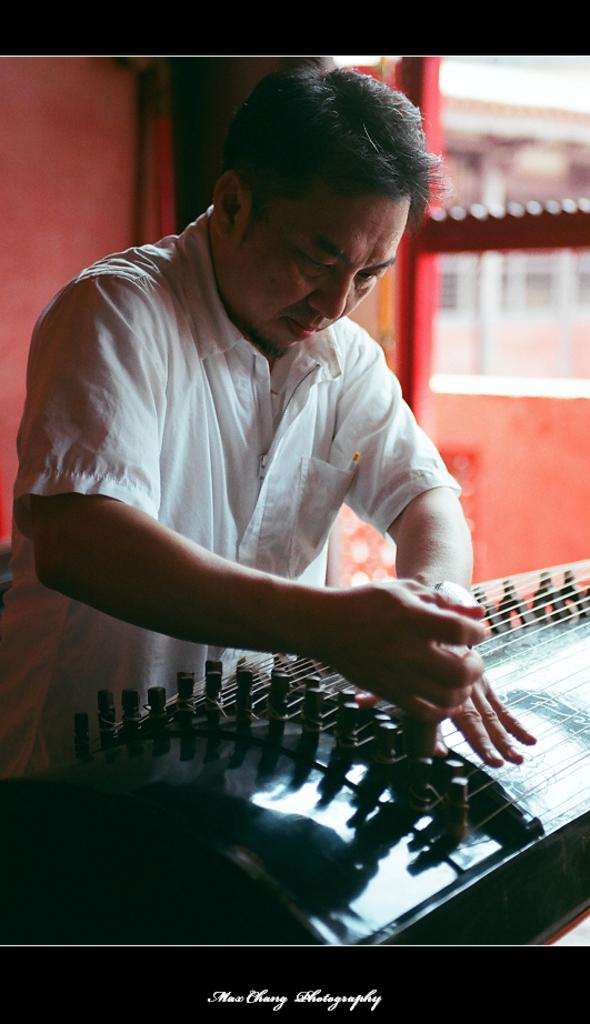Who is present in the image? There is a man in the image. What is the man wearing? The man is wearing clothes. What object can be seen in the image besides the man? There is a musical instrument in the image. Can you describe the background of the image? The background of the image is slightly blurred. What type of wrench is the man using to exchange recipes with the cook in the image? There is no wrench, exchange, or cook present in the image. 